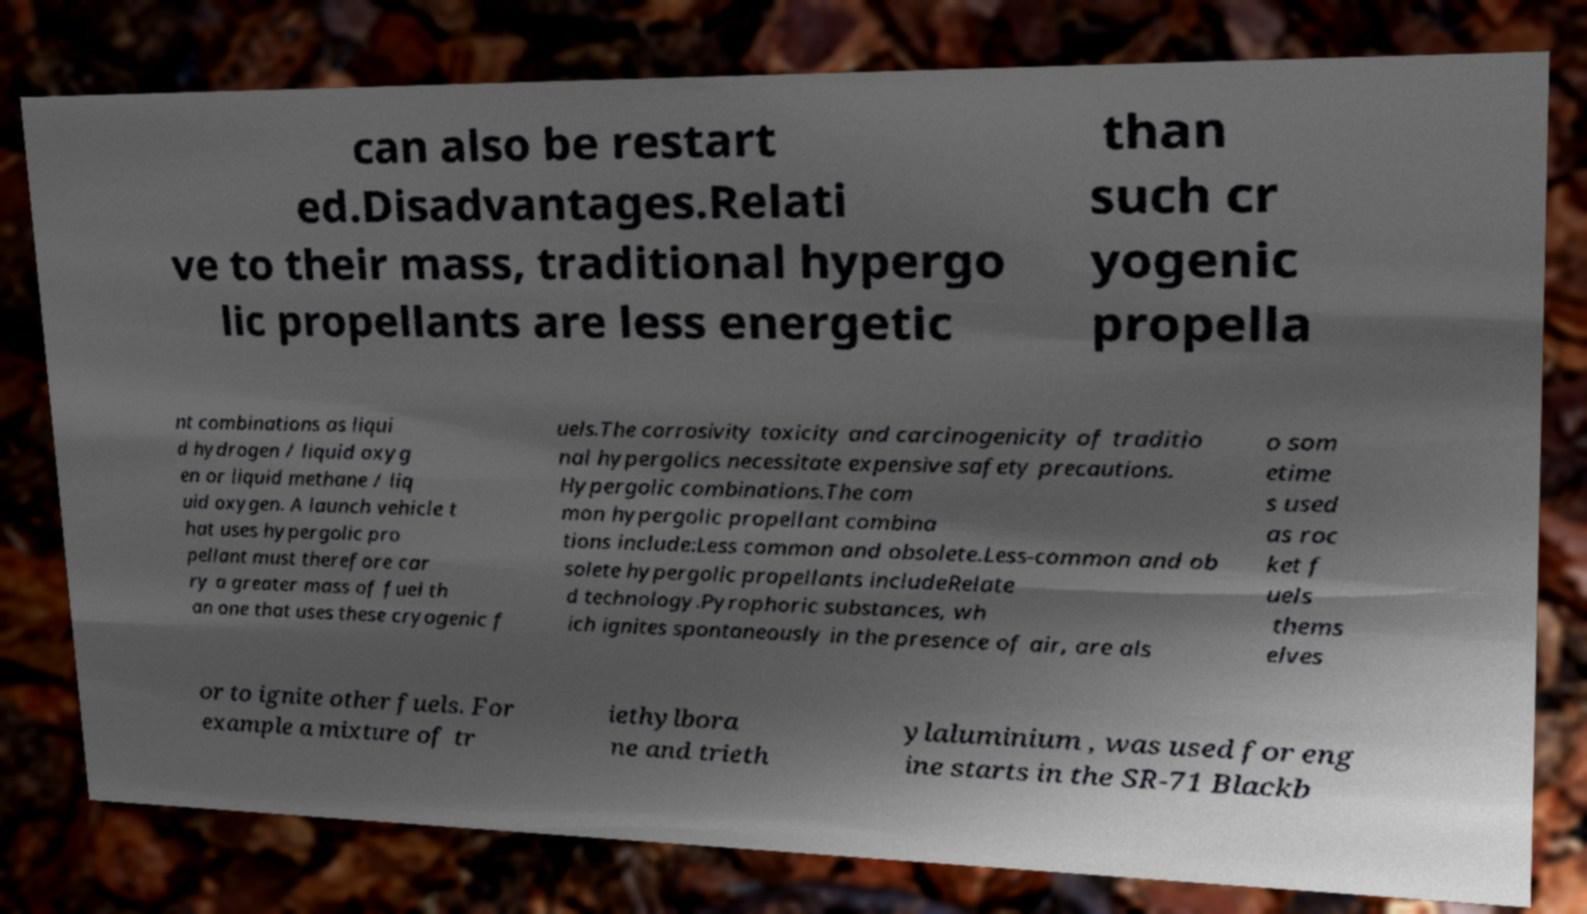Could you assist in decoding the text presented in this image and type it out clearly? can also be restart ed.Disadvantages.Relati ve to their mass, traditional hypergo lic propellants are less energetic than such cr yogenic propella nt combinations as liqui d hydrogen / liquid oxyg en or liquid methane / liq uid oxygen. A launch vehicle t hat uses hypergolic pro pellant must therefore car ry a greater mass of fuel th an one that uses these cryogenic f uels.The corrosivity toxicity and carcinogenicity of traditio nal hypergolics necessitate expensive safety precautions. Hypergolic combinations.The com mon hypergolic propellant combina tions include:Less common and obsolete.Less-common and ob solete hypergolic propellants includeRelate d technology.Pyrophoric substances, wh ich ignites spontaneously in the presence of air, are als o som etime s used as roc ket f uels thems elves or to ignite other fuels. For example a mixture of tr iethylbora ne and trieth ylaluminium , was used for eng ine starts in the SR-71 Blackb 